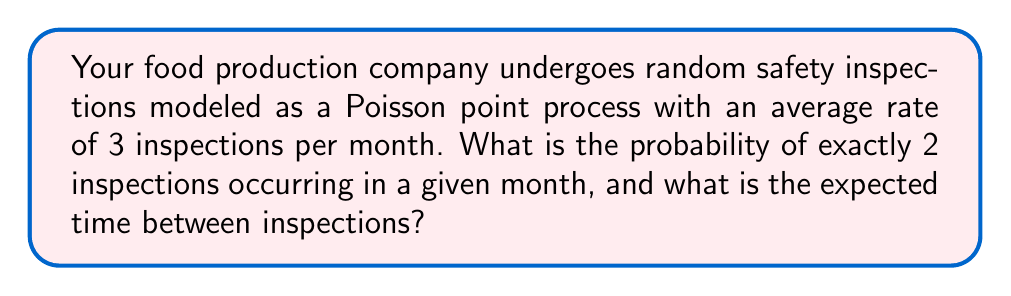Help me with this question. To solve this problem, we'll use the properties of Poisson point processes:

1. Probability of exactly k events in an interval:
   The probability of exactly k events occurring in an interval of length t is given by the Poisson distribution:
   
   $$P(N(t) = k) = \frac{(\lambda t)^k e^{-\lambda t}}{k!}$$

   where λ is the rate parameter and t is the time interval.

2. Expected time between events:
   For a Poisson process, the expected time between events is the reciprocal of the rate parameter.

Step 1: Calculate the probability of exactly 2 inspections in a month
- Rate parameter: λ = 3 inspections/month
- Time interval: t = 1 month
- Number of events: k = 2

Substituting into the Poisson probability formula:

$$P(N(1) = 2) = \frac{(3 \cdot 1)^2 e^{-3 \cdot 1}}{2!} = \frac{9e^{-3}}{2} \approx 0.2240$$

Step 2: Calculate the expected time between inspections
The expected time between inspections is the reciprocal of the rate parameter:

$$E[T] = \frac{1}{\lambda} = \frac{1}{3} \text{ month} = \frac{1}{3} \cdot 30 \text{ days} = 10 \text{ days}$$

Thus, the probability of exactly 2 inspections in a month is approximately 0.2240 or 22.40%, and the expected time between inspections is 10 days.
Answer: Probability: 0.2240; Expected time: 10 days 